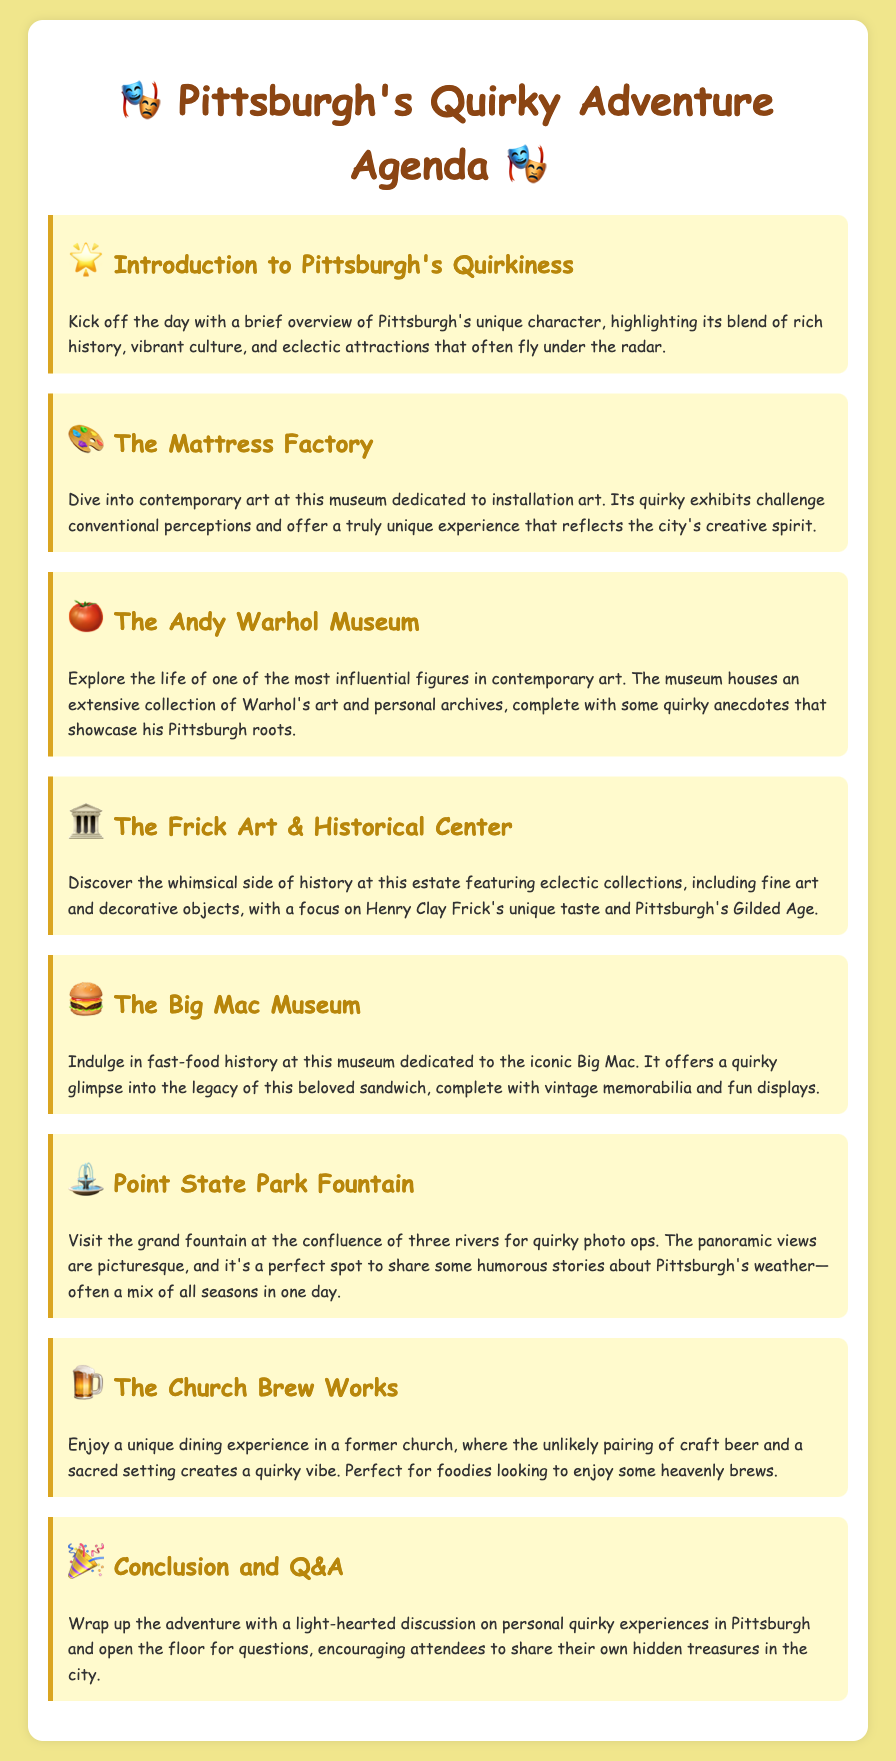What is the title of the agenda? The title is prominently displayed at the top of the document.
Answer: Pittsburgh's Best-Kept Secrets: A Guide to the City's Quirkiest Attractions What is the first attraction listed in the agenda? The first item on the agenda introduces participants to Pittsburgh's unique character.
Answer: Introduction to Pittsburgh's Quirkiness Which museum focuses on installation art? This information is provided in the description of one of the attractions.
Answer: The Mattress Factory What type of cuisine is offered at The Church Brew Works? The description of this attraction indicates the type of food experience provided.
Answer: Craft beer How many rivers meet at Point State Park Fountain? The document specifies the geographic location at which the fountain is situated.
Answer: Three What unique theme does The Big Mac Museum focus on? A brief description reveals the theme of this attraction.
Answer: Fast-food history Which attraction offers panoramic views? The location of this feature is detailed in the related agenda item.
Answer: Point State Park Fountain What type of setting is The Church Brew Works located in? The description provides context about the establishment's location.
Answer: Former church What is the final segment of the agenda? The last item wraps up the adventure and invites discussion.
Answer: Conclusion and Q&A 